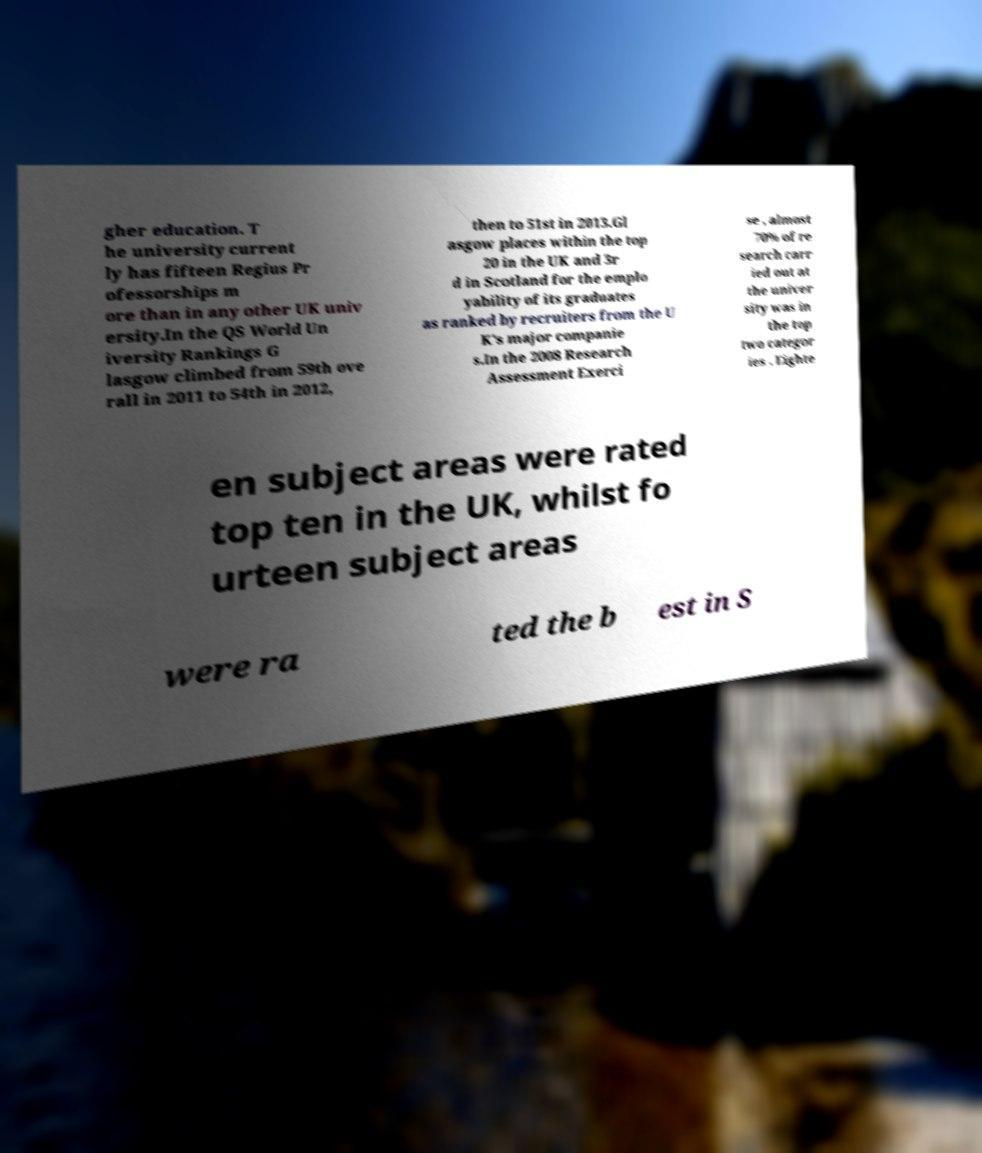Could you assist in decoding the text presented in this image and type it out clearly? gher education. T he university current ly has fifteen Regius Pr ofessorships m ore than in any other UK univ ersity.In the QS World Un iversity Rankings G lasgow climbed from 59th ove rall in 2011 to 54th in 2012, then to 51st in 2013.Gl asgow places within the top 20 in the UK and 3r d in Scotland for the emplo yability of its graduates as ranked by recruiters from the U K's major companie s.In the 2008 Research Assessment Exerci se , almost 70% of re search carr ied out at the univer sity was in the top two categor ies . Eighte en subject areas were rated top ten in the UK, whilst fo urteen subject areas were ra ted the b est in S 